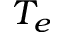<formula> <loc_0><loc_0><loc_500><loc_500>T _ { e }</formula> 